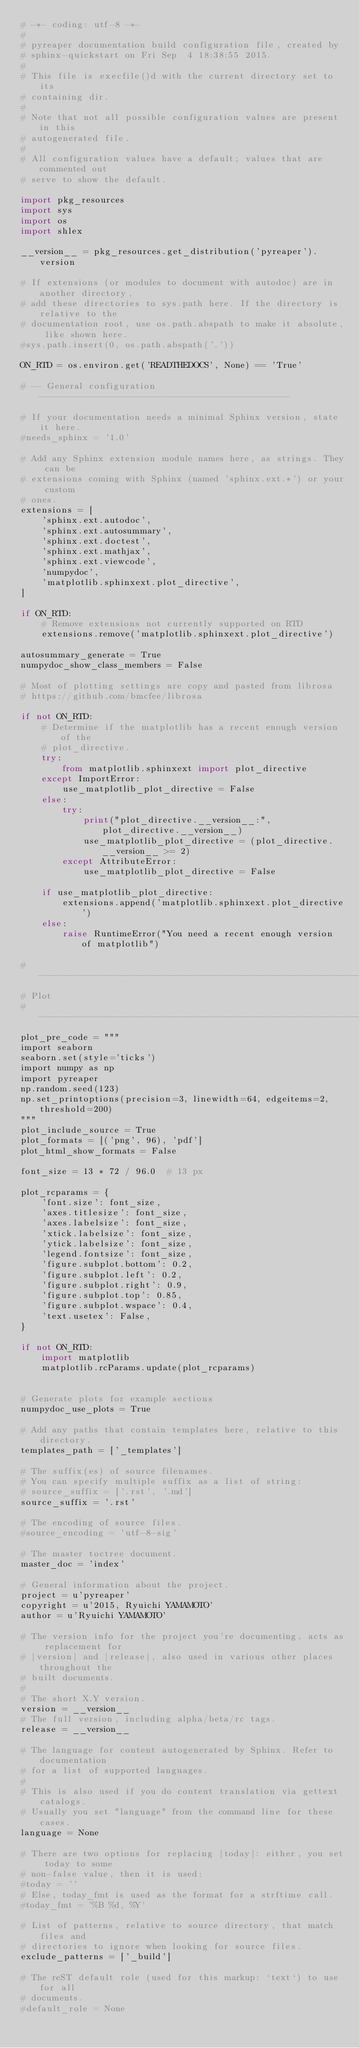Convert code to text. <code><loc_0><loc_0><loc_500><loc_500><_Python_># -*- coding: utf-8 -*-
#
# pyreaper documentation build configuration file, created by
# sphinx-quickstart on Fri Sep  4 18:38:55 2015.
#
# This file is execfile()d with the current directory set to its
# containing dir.
#
# Note that not all possible configuration values are present in this
# autogenerated file.
#
# All configuration values have a default; values that are commented out
# serve to show the default.

import pkg_resources
import sys
import os
import shlex

__version__ = pkg_resources.get_distribution('pyreaper').version

# If extensions (or modules to document with autodoc) are in another directory,
# add these directories to sys.path here. If the directory is relative to the
# documentation root, use os.path.abspath to make it absolute, like shown here.
#sys.path.insert(0, os.path.abspath('.'))

ON_RTD = os.environ.get('READTHEDOCS', None) == 'True'

# -- General configuration ------------------------------------------------

# If your documentation needs a minimal Sphinx version, state it here.
#needs_sphinx = '1.0'

# Add any Sphinx extension module names here, as strings. They can be
# extensions coming with Sphinx (named 'sphinx.ext.*') or your custom
# ones.
extensions = [
    'sphinx.ext.autodoc',
    'sphinx.ext.autosummary',
    'sphinx.ext.doctest',
    'sphinx.ext.mathjax',
    'sphinx.ext.viewcode',
    'numpydoc',
    'matplotlib.sphinxext.plot_directive',
]

if ON_RTD:
    # Remove extensions not currently supported on RTD
    extensions.remove('matplotlib.sphinxext.plot_directive')

autosummary_generate = True
numpydoc_show_class_members = False

# Most of plotting settings are copy and pasted from librosa
# https://github.com/bmcfee/librosa

if not ON_RTD:
    # Determine if the matplotlib has a recent enough version of the
    # plot_directive.
    try:
        from matplotlib.sphinxext import plot_directive
    except ImportError:
        use_matplotlib_plot_directive = False
    else:
        try:
            print("plot_directive.__version__:", plot_directive.__version__)
            use_matplotlib_plot_directive = (plot_directive.__version__ >= 2)
        except AttributeError:
            use_matplotlib_plot_directive = False

    if use_matplotlib_plot_directive:
        extensions.append('matplotlib.sphinxext.plot_directive')
    else:
        raise RuntimeError("You need a recent enough version of matplotlib")

#------------------------------------------------------------------------------
# Plot
#------------------------------------------------------------------------------
plot_pre_code = """
import seaborn
seaborn.set(style='ticks')
import numpy as np
import pyreaper
np.random.seed(123)
np.set_printoptions(precision=3, linewidth=64, edgeitems=2, threshold=200)
"""
plot_include_source = True
plot_formats = [('png', 96), 'pdf']
plot_html_show_formats = False

font_size = 13 * 72 / 96.0  # 13 px

plot_rcparams = {
    'font.size': font_size,
    'axes.titlesize': font_size,
    'axes.labelsize': font_size,
    'xtick.labelsize': font_size,
    'ytick.labelsize': font_size,
    'legend.fontsize': font_size,
    'figure.subplot.bottom': 0.2,
    'figure.subplot.left': 0.2,
    'figure.subplot.right': 0.9,
    'figure.subplot.top': 0.85,
    'figure.subplot.wspace': 0.4,
    'text.usetex': False,
}

if not ON_RTD:
    import matplotlib
    matplotlib.rcParams.update(plot_rcparams)


# Generate plots for example sections
numpydoc_use_plots = True

# Add any paths that contain templates here, relative to this directory.
templates_path = ['_templates']

# The suffix(es) of source filenames.
# You can specify multiple suffix as a list of string:
# source_suffix = ['.rst', '.md']
source_suffix = '.rst'

# The encoding of source files.
#source_encoding = 'utf-8-sig'

# The master toctree document.
master_doc = 'index'

# General information about the project.
project = u'pyreaper'
copyright = u'2015, Ryuichi YAMAMOTO'
author = u'Ryuichi YAMAMOTO'

# The version info for the project you're documenting, acts as replacement for
# |version| and |release|, also used in various other places throughout the
# built documents.
#
# The short X.Y version.
version = __version__
# The full version, including alpha/beta/rc tags.
release = __version__

# The language for content autogenerated by Sphinx. Refer to documentation
# for a list of supported languages.
#
# This is also used if you do content translation via gettext catalogs.
# Usually you set "language" from the command line for these cases.
language = None

# There are two options for replacing |today|: either, you set today to some
# non-false value, then it is used:
#today = ''
# Else, today_fmt is used as the format for a strftime call.
#today_fmt = '%B %d, %Y'

# List of patterns, relative to source directory, that match files and
# directories to ignore when looking for source files.
exclude_patterns = ['_build']

# The reST default role (used for this markup: `text`) to use for all
# documents.
#default_role = None
</code> 